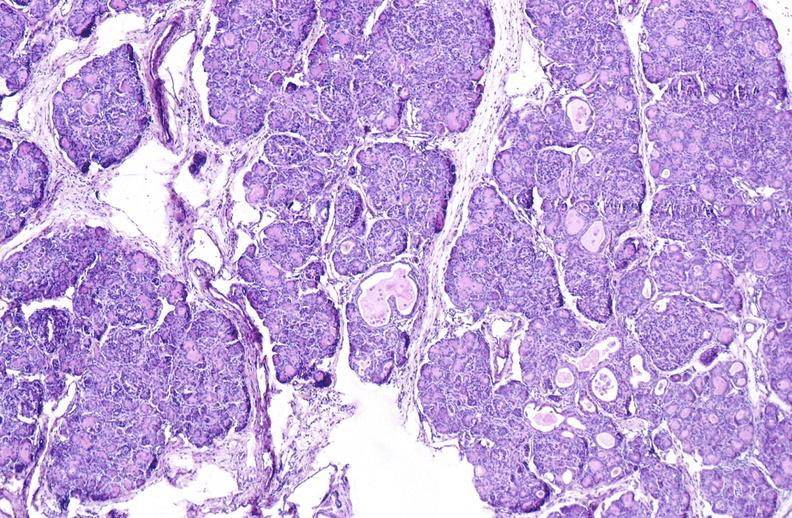does this image show cystic fibrosis?
Answer the question using a single word or phrase. Yes 